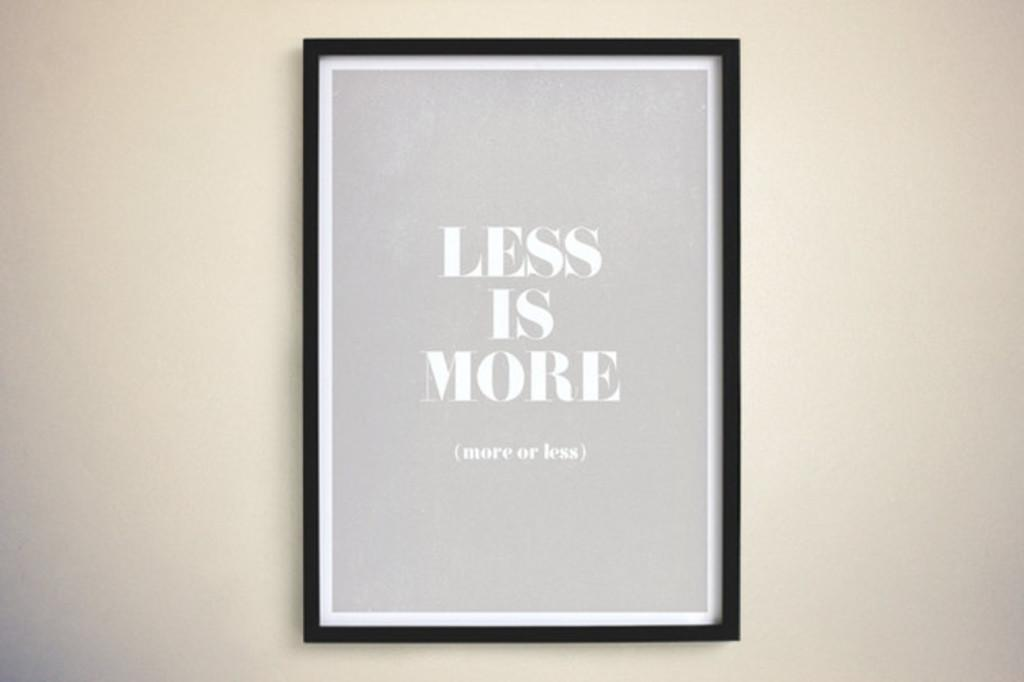Provide a one-sentence caption for the provided image. a frame with less is more or more or less written. 